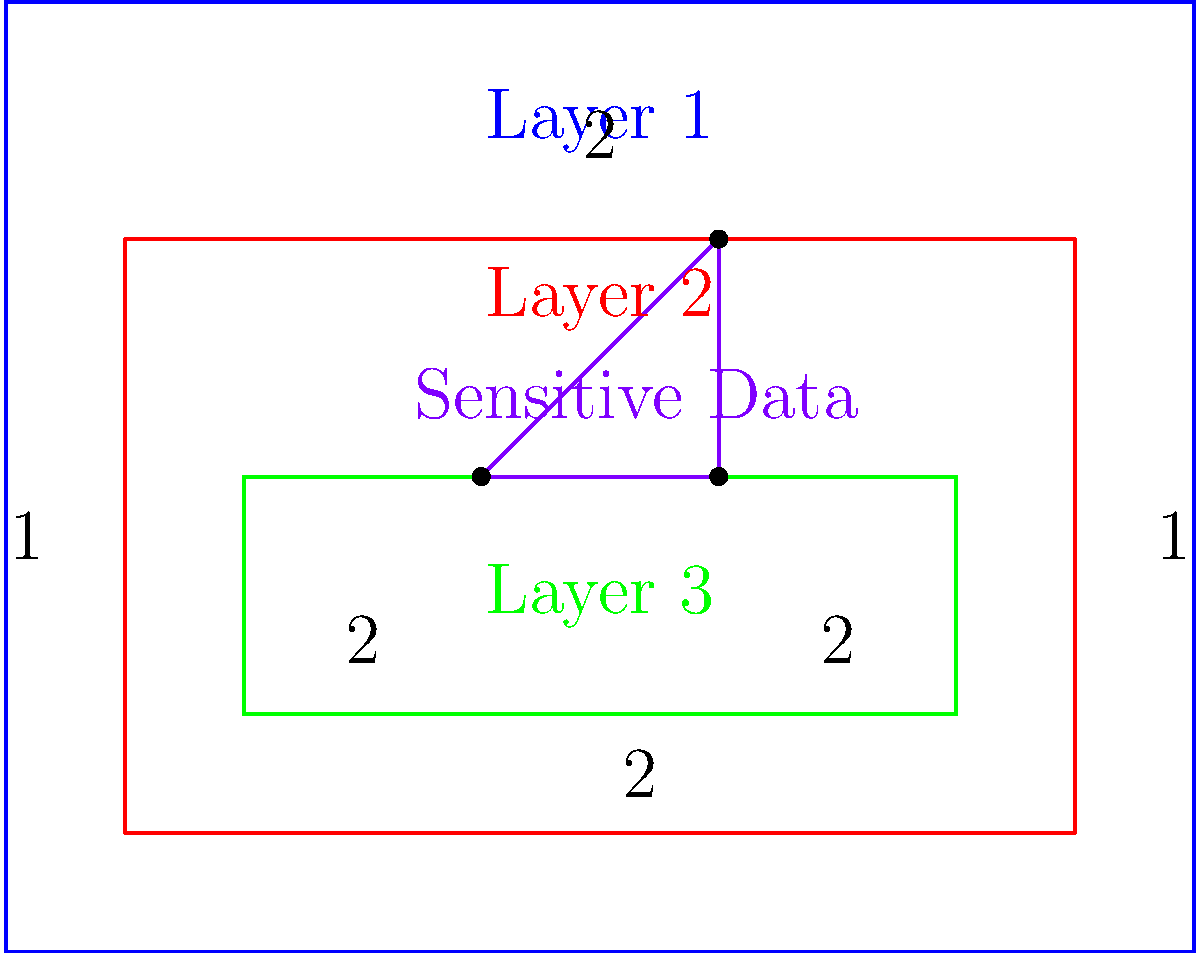In a multi-layered data protection system, the outer rectangle represents the perimeter security (Layer 1), the middle rectangle represents network security (Layer 2), and the inner rectangle represents application security (Layer 3). The triangle within Layer 3 represents the area where sensitive data is stored. If each unit in the diagram represents 10 square meters, calculate the total protected area (in square meters) that is not occupied by sensitive data. Let's break this down step-by-step:

1) First, calculate the areas of each layer:
   Layer 1 (outer rectangle): $10 \times 8 = 80$ units
   Layer 2 (middle rectangle): $8 \times 5 = 40$ units
   Layer 3 (inner rectangle): $6 \times 2 = 12$ units

2) Calculate the area of the sensitive data triangle:
   Base = 2 units, Height = 2 units
   Area of triangle = $\frac{1}{2} \times base \times height = \frac{1}{2} \times 2 \times 2 = 2$ units

3) Calculate the protected area not occupied by sensitive data:
   Total protected area = Layer 1 + Layer 2 + Layer 3 - Sensitive data area
   $= 80 + 40 + 12 - 2 = 130$ units

4) Convert units to square meters:
   Each unit represents 10 square meters
   Total area in square meters = $130 \times 10 = 1300$ square meters

Therefore, the total protected area not occupied by sensitive data is 1300 square meters.
Answer: 1300 square meters 